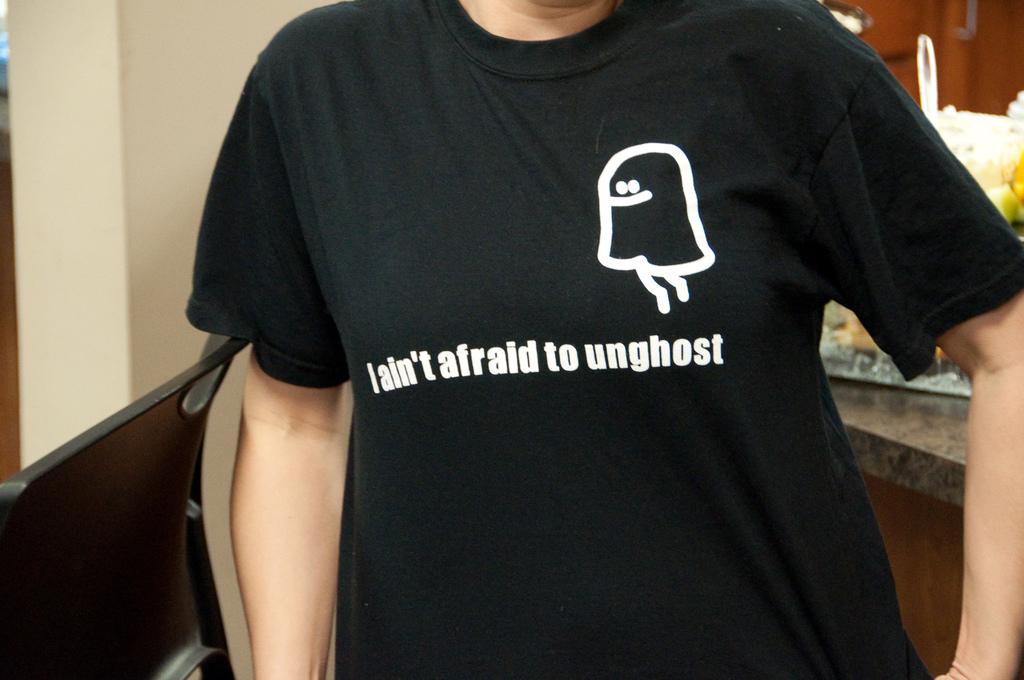What is the t-shirt's message?
Give a very brief answer. I ain't afraid to unghost. They aren't afraid to what?
Make the answer very short. Unghost. 